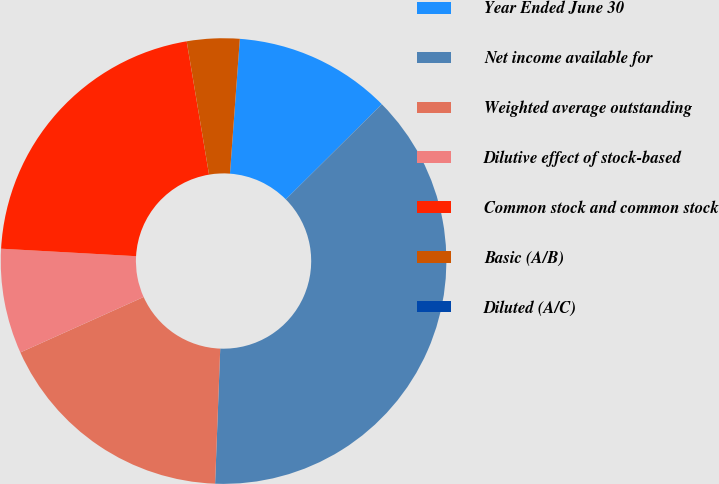Convert chart to OTSL. <chart><loc_0><loc_0><loc_500><loc_500><pie_chart><fcel>Year Ended June 30<fcel>Net income available for<fcel>Weighted average outstanding<fcel>Dilutive effect of stock-based<fcel>Common stock and common stock<fcel>Basic (A/B)<fcel>Diluted (A/C)<nl><fcel>11.41%<fcel>38.03%<fcel>17.67%<fcel>7.61%<fcel>21.47%<fcel>3.81%<fcel>0.0%<nl></chart> 